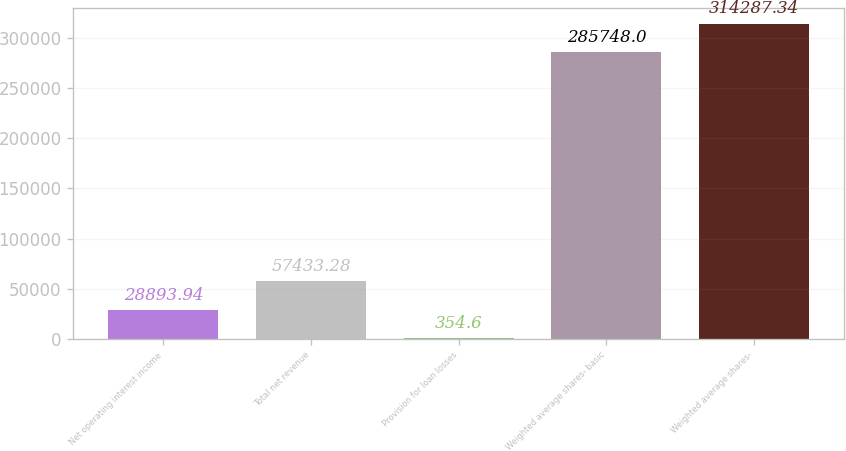<chart> <loc_0><loc_0><loc_500><loc_500><bar_chart><fcel>Net operating interest income<fcel>Total net revenue<fcel>Provision for loan losses<fcel>Weighted average shares- basic<fcel>Weighted average shares-<nl><fcel>28893.9<fcel>57433.3<fcel>354.6<fcel>285748<fcel>314287<nl></chart> 